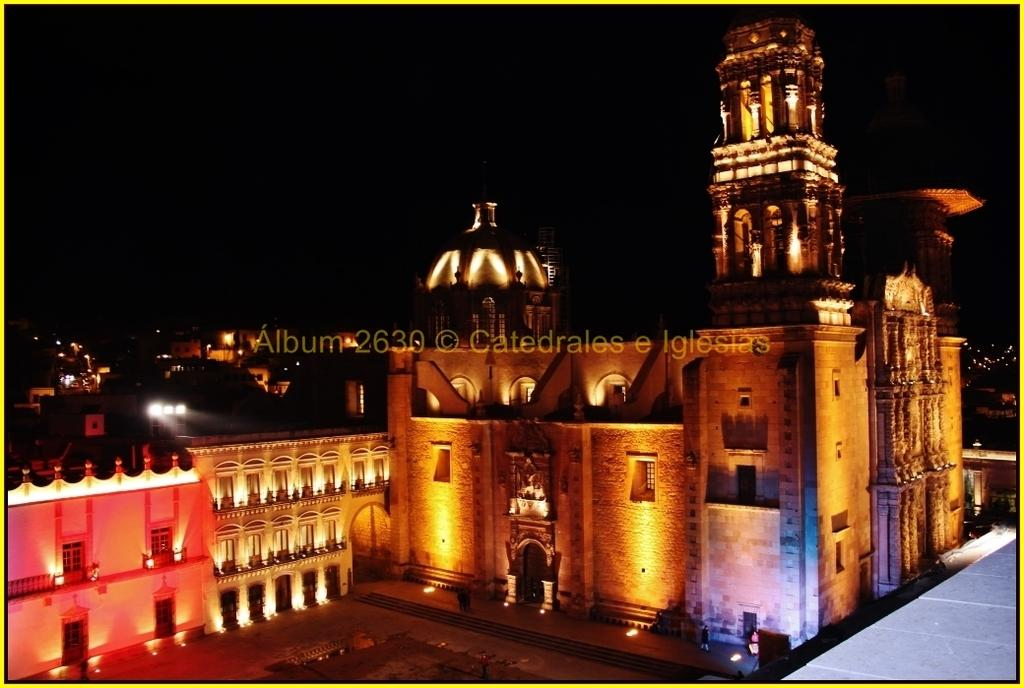Where was the image taken from? The image was taken from a website. What is the main subject of the image? There is a beautiful fort in the image. How is the fort illuminated in the image? The fort has many lights in the image. What can be seen behind the fort in the image? There are houses behind the fort in the image. What type of feather can be seen floating near the fort in the image? There is no feather present in the image; it only features the fort, lights, and houses. 